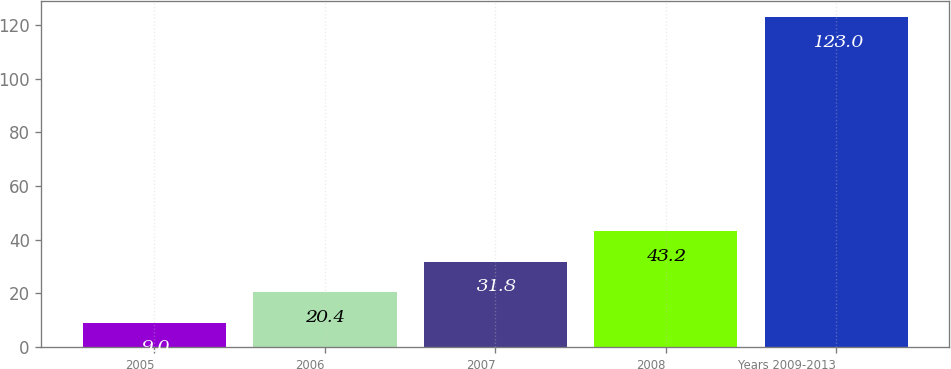Convert chart to OTSL. <chart><loc_0><loc_0><loc_500><loc_500><bar_chart><fcel>2005<fcel>2006<fcel>2007<fcel>2008<fcel>Years 2009-2013<nl><fcel>9<fcel>20.4<fcel>31.8<fcel>43.2<fcel>123<nl></chart> 